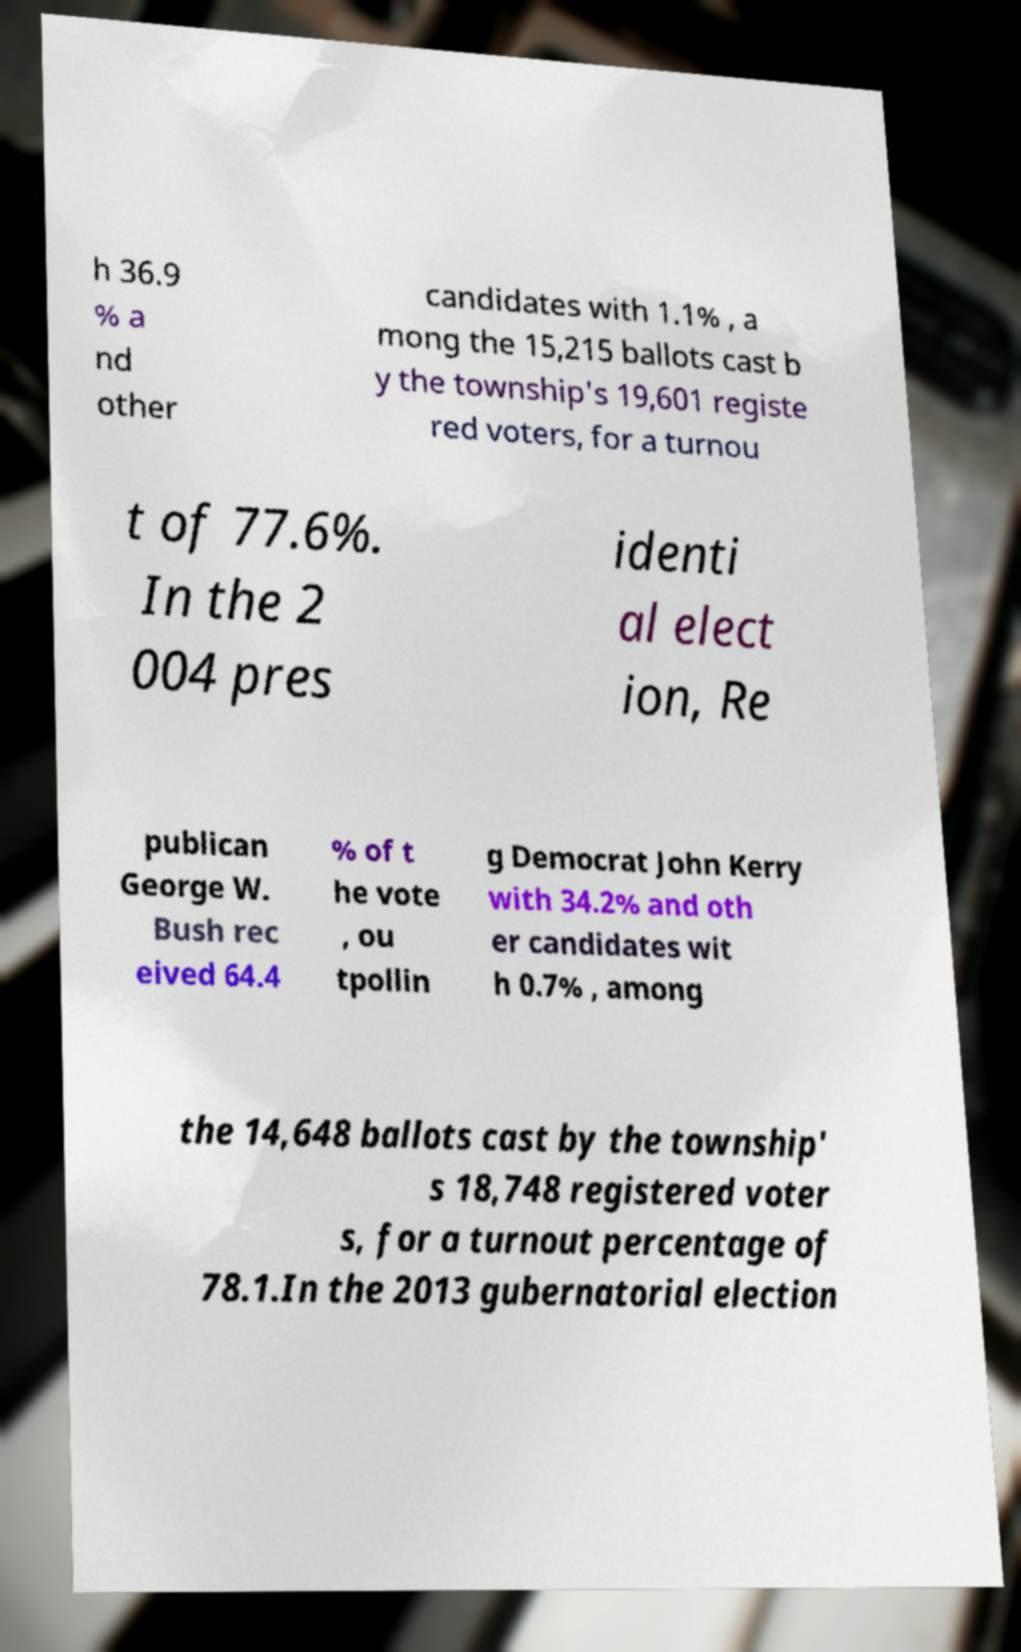Please identify and transcribe the text found in this image. h 36.9 % a nd other candidates with 1.1% , a mong the 15,215 ballots cast b y the township's 19,601 registe red voters, for a turnou t of 77.6%. In the 2 004 pres identi al elect ion, Re publican George W. Bush rec eived 64.4 % of t he vote , ou tpollin g Democrat John Kerry with 34.2% and oth er candidates wit h 0.7% , among the 14,648 ballots cast by the township' s 18,748 registered voter s, for a turnout percentage of 78.1.In the 2013 gubernatorial election 